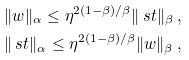Convert formula to latex. <formula><loc_0><loc_0><loc_500><loc_500>& \| w \| _ { \alpha } \leq \eta ^ { 2 ( 1 - \beta ) / \beta } \| \ s t \| _ { \beta } \ , \\ & \| \ s t \| _ { \alpha } \leq \eta ^ { 2 ( 1 - \beta ) / \beta } \| w \| _ { \beta } \ ,</formula> 